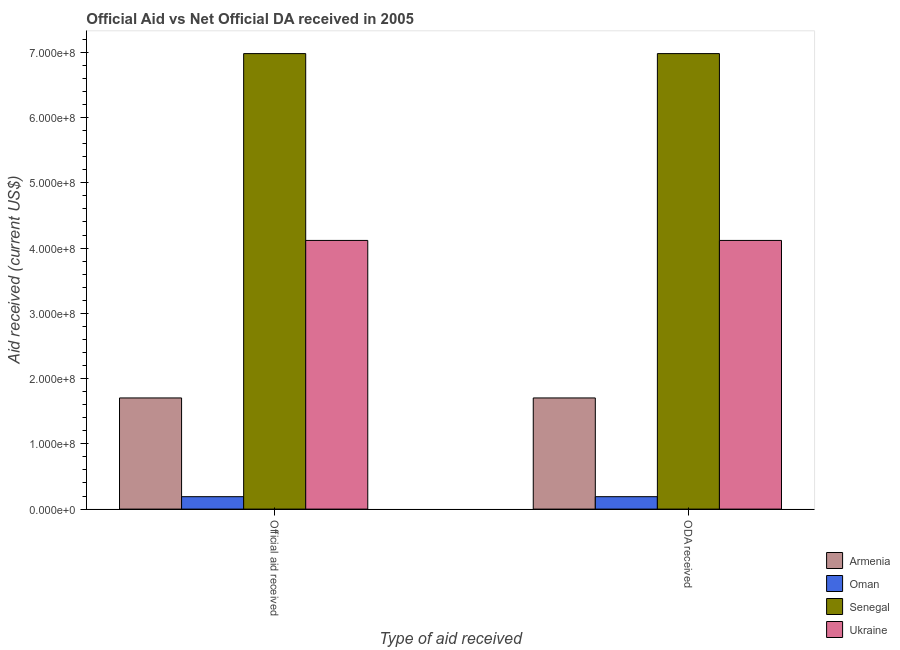How many different coloured bars are there?
Your answer should be compact. 4. How many groups of bars are there?
Your response must be concise. 2. Are the number of bars on each tick of the X-axis equal?
Your answer should be compact. Yes. How many bars are there on the 1st tick from the right?
Provide a short and direct response. 4. What is the label of the 1st group of bars from the left?
Offer a terse response. Official aid received. What is the oda received in Senegal?
Make the answer very short. 6.98e+08. Across all countries, what is the maximum official aid received?
Offer a very short reply. 6.98e+08. Across all countries, what is the minimum official aid received?
Provide a short and direct response. 1.90e+07. In which country was the oda received maximum?
Ensure brevity in your answer.  Senegal. In which country was the oda received minimum?
Ensure brevity in your answer.  Oman. What is the total official aid received in the graph?
Provide a succinct answer. 1.30e+09. What is the difference between the official aid received in Armenia and that in Oman?
Make the answer very short. 1.51e+08. What is the difference between the official aid received in Oman and the oda received in Ukraine?
Your answer should be compact. -3.93e+08. What is the average oda received per country?
Your answer should be very brief. 3.25e+08. In how many countries, is the official aid received greater than 440000000 US$?
Ensure brevity in your answer.  1. What is the ratio of the oda received in Armenia to that in Senegal?
Make the answer very short. 0.24. Is the oda received in Armenia less than that in Ukraine?
Offer a very short reply. Yes. In how many countries, is the official aid received greater than the average official aid received taken over all countries?
Make the answer very short. 2. What does the 1st bar from the left in ODA received represents?
Your response must be concise. Armenia. What does the 2nd bar from the right in ODA received represents?
Your response must be concise. Senegal. Are all the bars in the graph horizontal?
Provide a short and direct response. No. Does the graph contain any zero values?
Make the answer very short. No. Does the graph contain grids?
Provide a short and direct response. No. Where does the legend appear in the graph?
Keep it short and to the point. Bottom right. How many legend labels are there?
Offer a terse response. 4. How are the legend labels stacked?
Offer a terse response. Vertical. What is the title of the graph?
Ensure brevity in your answer.  Official Aid vs Net Official DA received in 2005 . What is the label or title of the X-axis?
Provide a short and direct response. Type of aid received. What is the label or title of the Y-axis?
Your answer should be very brief. Aid received (current US$). What is the Aid received (current US$) in Armenia in Official aid received?
Make the answer very short. 1.70e+08. What is the Aid received (current US$) of Oman in Official aid received?
Provide a short and direct response. 1.90e+07. What is the Aid received (current US$) in Senegal in Official aid received?
Keep it short and to the point. 6.98e+08. What is the Aid received (current US$) in Ukraine in Official aid received?
Give a very brief answer. 4.12e+08. What is the Aid received (current US$) in Armenia in ODA received?
Make the answer very short. 1.70e+08. What is the Aid received (current US$) in Oman in ODA received?
Keep it short and to the point. 1.90e+07. What is the Aid received (current US$) of Senegal in ODA received?
Your response must be concise. 6.98e+08. What is the Aid received (current US$) in Ukraine in ODA received?
Your answer should be compact. 4.12e+08. Across all Type of aid received, what is the maximum Aid received (current US$) in Armenia?
Make the answer very short. 1.70e+08. Across all Type of aid received, what is the maximum Aid received (current US$) in Oman?
Ensure brevity in your answer.  1.90e+07. Across all Type of aid received, what is the maximum Aid received (current US$) in Senegal?
Make the answer very short. 6.98e+08. Across all Type of aid received, what is the maximum Aid received (current US$) in Ukraine?
Provide a succinct answer. 4.12e+08. Across all Type of aid received, what is the minimum Aid received (current US$) of Armenia?
Give a very brief answer. 1.70e+08. Across all Type of aid received, what is the minimum Aid received (current US$) in Oman?
Offer a terse response. 1.90e+07. Across all Type of aid received, what is the minimum Aid received (current US$) of Senegal?
Ensure brevity in your answer.  6.98e+08. Across all Type of aid received, what is the minimum Aid received (current US$) of Ukraine?
Offer a very short reply. 4.12e+08. What is the total Aid received (current US$) in Armenia in the graph?
Ensure brevity in your answer.  3.41e+08. What is the total Aid received (current US$) of Oman in the graph?
Your answer should be very brief. 3.81e+07. What is the total Aid received (current US$) in Senegal in the graph?
Provide a short and direct response. 1.40e+09. What is the total Aid received (current US$) of Ukraine in the graph?
Offer a terse response. 8.23e+08. What is the difference between the Aid received (current US$) of Senegal in Official aid received and that in ODA received?
Offer a very short reply. 0. What is the difference between the Aid received (current US$) of Armenia in Official aid received and the Aid received (current US$) of Oman in ODA received?
Your answer should be compact. 1.51e+08. What is the difference between the Aid received (current US$) of Armenia in Official aid received and the Aid received (current US$) of Senegal in ODA received?
Your answer should be compact. -5.28e+08. What is the difference between the Aid received (current US$) in Armenia in Official aid received and the Aid received (current US$) in Ukraine in ODA received?
Offer a terse response. -2.41e+08. What is the difference between the Aid received (current US$) of Oman in Official aid received and the Aid received (current US$) of Senegal in ODA received?
Offer a terse response. -6.79e+08. What is the difference between the Aid received (current US$) in Oman in Official aid received and the Aid received (current US$) in Ukraine in ODA received?
Provide a short and direct response. -3.93e+08. What is the difference between the Aid received (current US$) of Senegal in Official aid received and the Aid received (current US$) of Ukraine in ODA received?
Make the answer very short. 2.86e+08. What is the average Aid received (current US$) in Armenia per Type of aid received?
Your answer should be very brief. 1.70e+08. What is the average Aid received (current US$) of Oman per Type of aid received?
Provide a succinct answer. 1.90e+07. What is the average Aid received (current US$) of Senegal per Type of aid received?
Ensure brevity in your answer.  6.98e+08. What is the average Aid received (current US$) of Ukraine per Type of aid received?
Your answer should be compact. 4.12e+08. What is the difference between the Aid received (current US$) in Armenia and Aid received (current US$) in Oman in Official aid received?
Ensure brevity in your answer.  1.51e+08. What is the difference between the Aid received (current US$) of Armenia and Aid received (current US$) of Senegal in Official aid received?
Keep it short and to the point. -5.28e+08. What is the difference between the Aid received (current US$) of Armenia and Aid received (current US$) of Ukraine in Official aid received?
Provide a short and direct response. -2.41e+08. What is the difference between the Aid received (current US$) in Oman and Aid received (current US$) in Senegal in Official aid received?
Offer a terse response. -6.79e+08. What is the difference between the Aid received (current US$) of Oman and Aid received (current US$) of Ukraine in Official aid received?
Ensure brevity in your answer.  -3.93e+08. What is the difference between the Aid received (current US$) in Senegal and Aid received (current US$) in Ukraine in Official aid received?
Your response must be concise. 2.86e+08. What is the difference between the Aid received (current US$) of Armenia and Aid received (current US$) of Oman in ODA received?
Your answer should be very brief. 1.51e+08. What is the difference between the Aid received (current US$) in Armenia and Aid received (current US$) in Senegal in ODA received?
Make the answer very short. -5.28e+08. What is the difference between the Aid received (current US$) of Armenia and Aid received (current US$) of Ukraine in ODA received?
Your response must be concise. -2.41e+08. What is the difference between the Aid received (current US$) of Oman and Aid received (current US$) of Senegal in ODA received?
Keep it short and to the point. -6.79e+08. What is the difference between the Aid received (current US$) in Oman and Aid received (current US$) in Ukraine in ODA received?
Keep it short and to the point. -3.93e+08. What is the difference between the Aid received (current US$) in Senegal and Aid received (current US$) in Ukraine in ODA received?
Make the answer very short. 2.86e+08. What is the ratio of the Aid received (current US$) in Oman in Official aid received to that in ODA received?
Your answer should be very brief. 1. What is the difference between the highest and the second highest Aid received (current US$) in Armenia?
Offer a terse response. 0. What is the difference between the highest and the second highest Aid received (current US$) of Ukraine?
Offer a terse response. 0. What is the difference between the highest and the lowest Aid received (current US$) in Oman?
Keep it short and to the point. 0. What is the difference between the highest and the lowest Aid received (current US$) in Ukraine?
Offer a terse response. 0. 